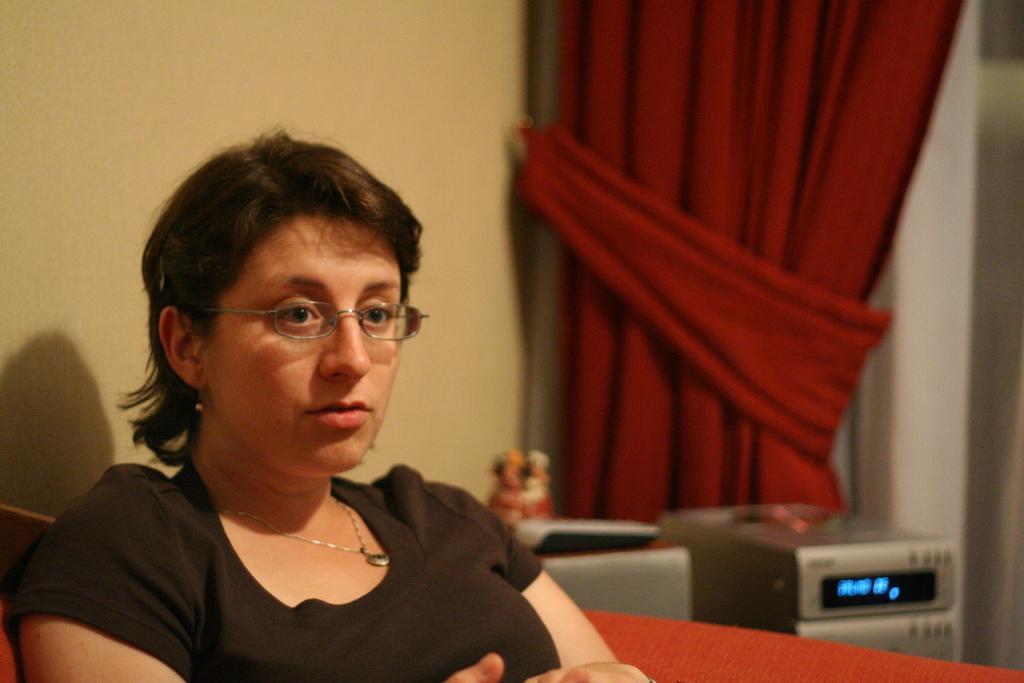Who is in the picture? There is a woman in the picture. What is the woman doing in the picture? The woman is sitting. What is the woman wearing in the picture? The woman is wearing spectacles. Where is the woman sitting in the picture? The woman is sitting on a couch. What can be seen in the background of the picture? There is a wall and a curtain in the background of the picture. What type of haircut does the woman have in the garden? There is no garden present in the image, and the woman's haircut cannot be determined from the image. What is the woman doing with her neck in the picture? The woman's neck is not doing anything in the picture, as it is simply part of her body. 